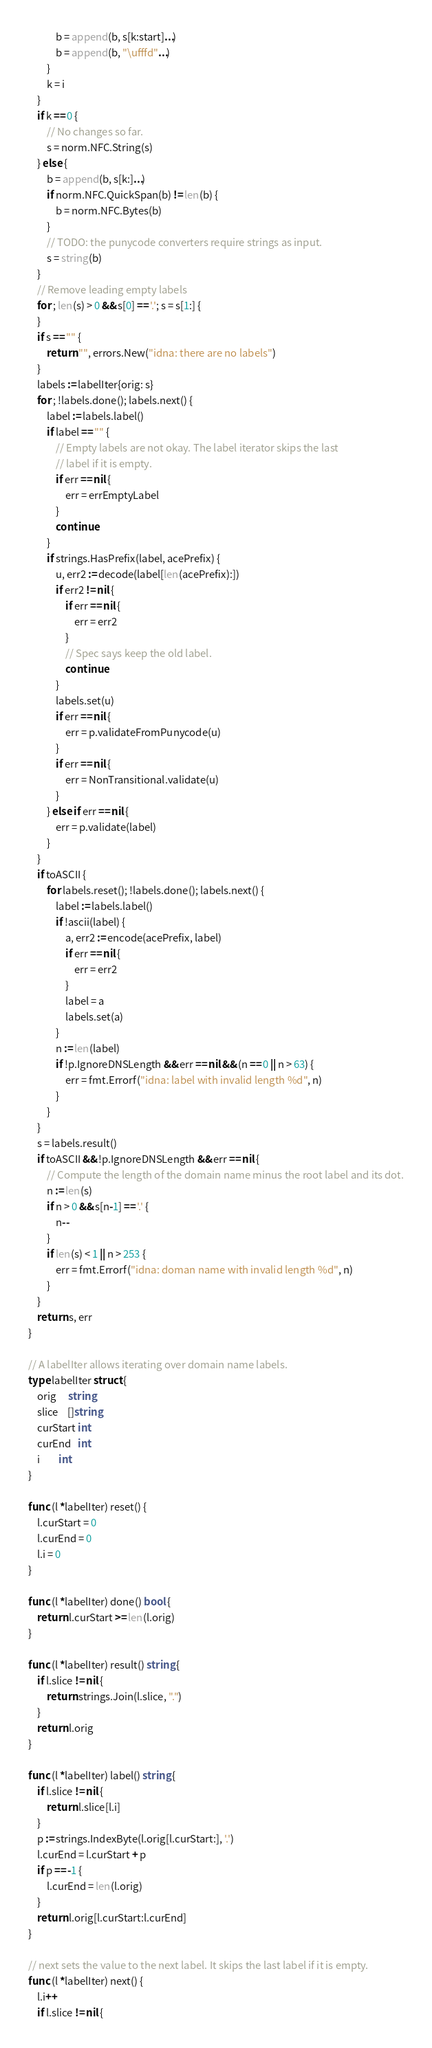Convert code to text. <code><loc_0><loc_0><loc_500><loc_500><_Go_>			b = append(b, s[k:start]...)
			b = append(b, "\ufffd"...)
		}
		k = i
	}
	if k == 0 {
		// No changes so far.
		s = norm.NFC.String(s)
	} else {
		b = append(b, s[k:]...)
		if norm.NFC.QuickSpan(b) != len(b) {
			b = norm.NFC.Bytes(b)
		}
		// TODO: the punycode converters require strings as input.
		s = string(b)
	}
	// Remove leading empty labels
	for ; len(s) > 0 && s[0] == '.'; s = s[1:] {
	}
	if s == "" {
		return "", errors.New("idna: there are no labels")
	}
	labels := labelIter{orig: s}
	for ; !labels.done(); labels.next() {
		label := labels.label()
		if label == "" {
			// Empty labels are not okay. The label iterator skips the last
			// label if it is empty.
			if err == nil {
				err = errEmptyLabel
			}
			continue
		}
		if strings.HasPrefix(label, acePrefix) {
			u, err2 := decode(label[len(acePrefix):])
			if err2 != nil {
				if err == nil {
					err = err2
				}
				// Spec says keep the old label.
				continue
			}
			labels.set(u)
			if err == nil {
				err = p.validateFromPunycode(u)
			}
			if err == nil {
				err = NonTransitional.validate(u)
			}
		} else if err == nil {
			err = p.validate(label)
		}
	}
	if toASCII {
		for labels.reset(); !labels.done(); labels.next() {
			label := labels.label()
			if !ascii(label) {
				a, err2 := encode(acePrefix, label)
				if err == nil {
					err = err2
				}
				label = a
				labels.set(a)
			}
			n := len(label)
			if !p.IgnoreDNSLength && err == nil && (n == 0 || n > 63) {
				err = fmt.Errorf("idna: label with invalid length %d", n)
			}
		}
	}
	s = labels.result()
	if toASCII && !p.IgnoreDNSLength && err == nil {
		// Compute the length of the domain name minus the root label and its dot.
		n := len(s)
		if n > 0 && s[n-1] == '.' {
			n--
		}
		if len(s) < 1 || n > 253 {
			err = fmt.Errorf("idna: doman name with invalid length %d", n)
		}
	}
	return s, err
}

// A labelIter allows iterating over domain name labels.
type labelIter struct {
	orig     string
	slice    []string
	curStart int
	curEnd   int
	i        int
}

func (l *labelIter) reset() {
	l.curStart = 0
	l.curEnd = 0
	l.i = 0
}

func (l *labelIter) done() bool {
	return l.curStart >= len(l.orig)
}

func (l *labelIter) result() string {
	if l.slice != nil {
		return strings.Join(l.slice, ".")
	}
	return l.orig
}

func (l *labelIter) label() string {
	if l.slice != nil {
		return l.slice[l.i]
	}
	p := strings.IndexByte(l.orig[l.curStart:], '.')
	l.curEnd = l.curStart + p
	if p == -1 {
		l.curEnd = len(l.orig)
	}
	return l.orig[l.curStart:l.curEnd]
}

// next sets the value to the next label. It skips the last label if it is empty.
func (l *labelIter) next() {
	l.i++
	if l.slice != nil {</code> 